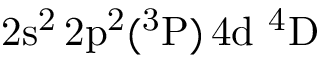Convert formula to latex. <formula><loc_0><loc_0><loc_500><loc_500>2 s ^ { 2 } \, 2 p ^ { 2 } ( ^ { 3 } P ) \, 4 d ^ { 4 } D</formula> 